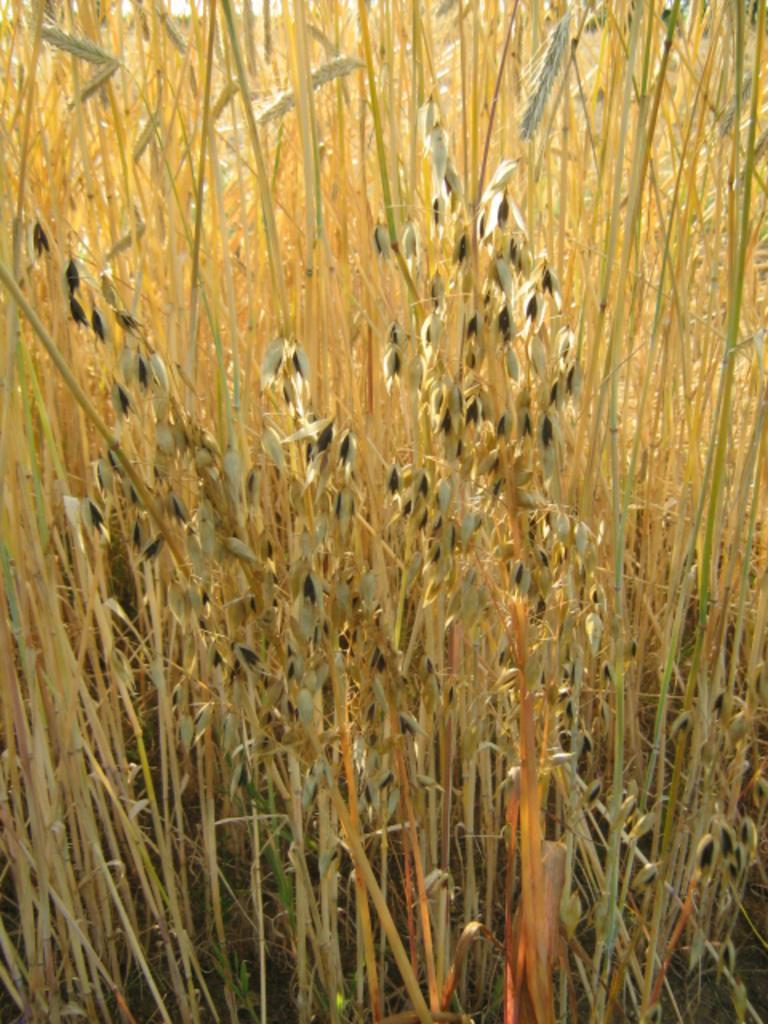In one or two sentences, can you explain what this image depicts? In this image I can see few plants which are brown in color and few objects to the plants which are black in color. 